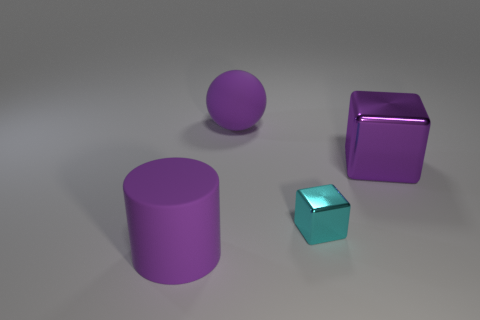Is the number of objects to the right of the matte sphere less than the number of objects?
Your answer should be compact. Yes. There is a metal thing left of the purple cube; does it have the same shape as the large purple metallic object behind the cyan cube?
Ensure brevity in your answer.  Yes. What number of objects are either big purple rubber objects that are on the left side of the ball or large metal things?
Keep it short and to the point. 2. What material is the ball that is the same color as the big metallic cube?
Your answer should be very brief. Rubber. There is a big purple matte object left of the large purple rubber object behind the tiny cyan thing; are there any big matte things right of it?
Your answer should be very brief. Yes. Is the number of purple things that are in front of the purple rubber cylinder less than the number of purple objects that are on the left side of the large metal object?
Your answer should be compact. Yes. There is a large cylinder that is the same material as the large sphere; what color is it?
Your answer should be compact. Purple. What color is the matte object that is in front of the shiny object in front of the large purple metal cube?
Your answer should be very brief. Purple. Are there any other objects of the same color as the small thing?
Your answer should be very brief. No. There is a metal object that is the same size as the ball; what is its shape?
Give a very brief answer. Cube. 